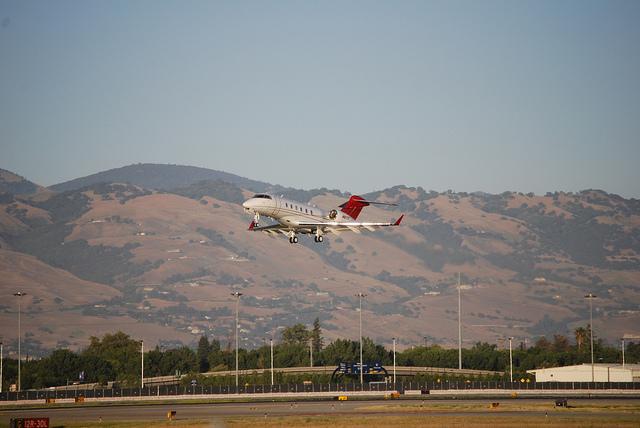Are there any bushes?
Write a very short answer. Yes. What is the white speck in the sky?
Answer briefly. Plane. Is the plane in motion?
Keep it brief. Yes. What is in the background?
Concise answer only. Mountains. What vehicle is in the image?
Write a very short answer. Airplane. What type of vehicle is featured?
Concise answer only. Airplane. What is on the mountain tops?
Concise answer only. Trees. Are there mountains in the background?
Answer briefly. Yes. How many yellow stripes are on the road?
Keep it brief. 1. Is the plane landing in the desert?
Concise answer only. No. Would this make a good postcard view?
Give a very brief answer. Yes. 